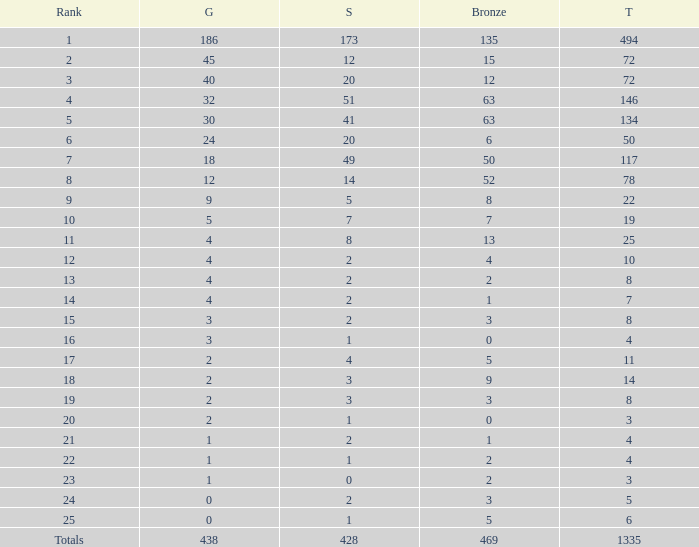What is the total amount of gold medals when there were more than 20 silvers and there were 135 bronze medals? 1.0. 